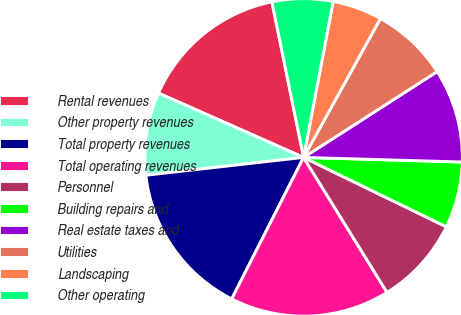Convert chart to OTSL. <chart><loc_0><loc_0><loc_500><loc_500><pie_chart><fcel>Rental revenues<fcel>Other property revenues<fcel>Total property revenues<fcel>Total operating revenues<fcel>Personnel<fcel>Building repairs and<fcel>Real estate taxes and<fcel>Utilities<fcel>Landscaping<fcel>Other operating<nl><fcel>15.17%<fcel>8.43%<fcel>15.73%<fcel>16.29%<fcel>8.99%<fcel>6.74%<fcel>9.55%<fcel>7.87%<fcel>5.06%<fcel>6.18%<nl></chart> 